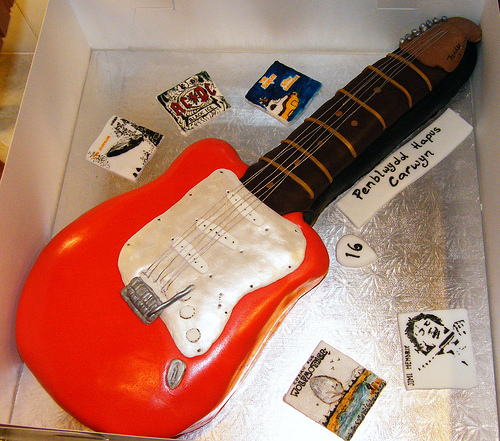<image>
Can you confirm if the guitar is under the picture? No. The guitar is not positioned under the picture. The vertical relationship between these objects is different. 